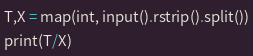<code> <loc_0><loc_0><loc_500><loc_500><_Python_>T,X = map(int, input().rstrip().split())
print(T/X)</code> 